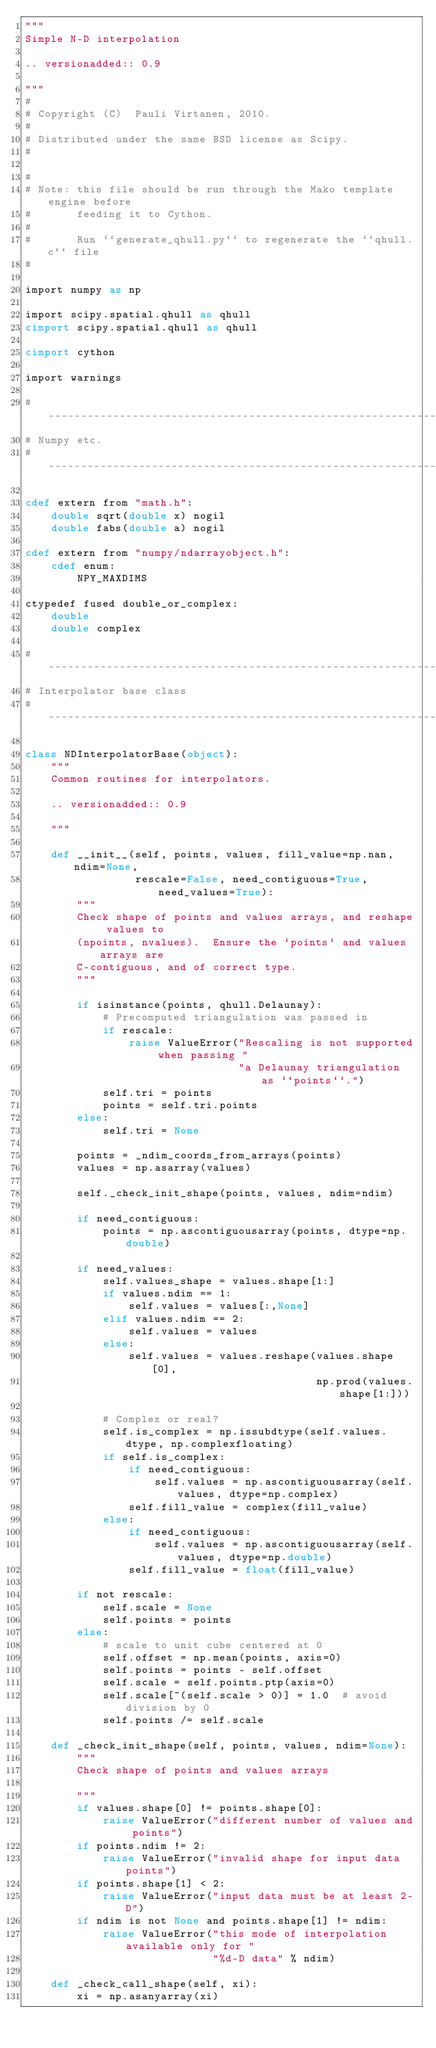Convert code to text. <code><loc_0><loc_0><loc_500><loc_500><_Cython_>"""
Simple N-D interpolation

.. versionadded:: 0.9

"""
#
# Copyright (C)  Pauli Virtanen, 2010.
#
# Distributed under the same BSD license as Scipy.
#

#
# Note: this file should be run through the Mako template engine before
#       feeding it to Cython.
#
#       Run ``generate_qhull.py`` to regenerate the ``qhull.c`` file
#

import numpy as np

import scipy.spatial.qhull as qhull
cimport scipy.spatial.qhull as qhull

cimport cython

import warnings

#------------------------------------------------------------------------------
# Numpy etc.
#------------------------------------------------------------------------------

cdef extern from "math.h":
    double sqrt(double x) nogil
    double fabs(double a) nogil

cdef extern from "numpy/ndarrayobject.h":
    cdef enum:
        NPY_MAXDIMS

ctypedef fused double_or_complex:
    double
    double complex

#------------------------------------------------------------------------------
# Interpolator base class
#------------------------------------------------------------------------------

class NDInterpolatorBase(object):
    """
    Common routines for interpolators.

    .. versionadded:: 0.9

    """

    def __init__(self, points, values, fill_value=np.nan, ndim=None,
                 rescale=False, need_contiguous=True, need_values=True):
        """
        Check shape of points and values arrays, and reshape values to
        (npoints, nvalues).  Ensure the `points` and values arrays are
        C-contiguous, and of correct type.
        """

        if isinstance(points, qhull.Delaunay):
            # Precomputed triangulation was passed in
            if rescale:
                raise ValueError("Rescaling is not supported when passing "
                                 "a Delaunay triangulation as ``points``.")
            self.tri = points
            points = self.tri.points
        else:
            self.tri = None

        points = _ndim_coords_from_arrays(points)
        values = np.asarray(values)

        self._check_init_shape(points, values, ndim=ndim)

        if need_contiguous:
            points = np.ascontiguousarray(points, dtype=np.double)

        if need_values:
            self.values_shape = values.shape[1:]
            if values.ndim == 1:
                self.values = values[:,None]
            elif values.ndim == 2:
                self.values = values
            else:
                self.values = values.reshape(values.shape[0],
                                             np.prod(values.shape[1:]))

            # Complex or real?
            self.is_complex = np.issubdtype(self.values.dtype, np.complexfloating)
            if self.is_complex:
                if need_contiguous:
                    self.values = np.ascontiguousarray(self.values, dtype=np.complex)
                self.fill_value = complex(fill_value)
            else:
                if need_contiguous:
                    self.values = np.ascontiguousarray(self.values, dtype=np.double)
                self.fill_value = float(fill_value)

        if not rescale:
            self.scale = None
            self.points = points
        else:
            # scale to unit cube centered at 0
            self.offset = np.mean(points, axis=0)
            self.points = points - self.offset
            self.scale = self.points.ptp(axis=0)
            self.scale[~(self.scale > 0)] = 1.0  # avoid division by 0
            self.points /= self.scale

    def _check_init_shape(self, points, values, ndim=None):
        """
        Check shape of points and values arrays

        """
        if values.shape[0] != points.shape[0]:
            raise ValueError("different number of values and points")
        if points.ndim != 2:
            raise ValueError("invalid shape for input data points")
        if points.shape[1] < 2:
            raise ValueError("input data must be at least 2-D")
        if ndim is not None and points.shape[1] != ndim:
            raise ValueError("this mode of interpolation available only for "
                             "%d-D data" % ndim)

    def _check_call_shape(self, xi):
        xi = np.asanyarray(xi)</code> 